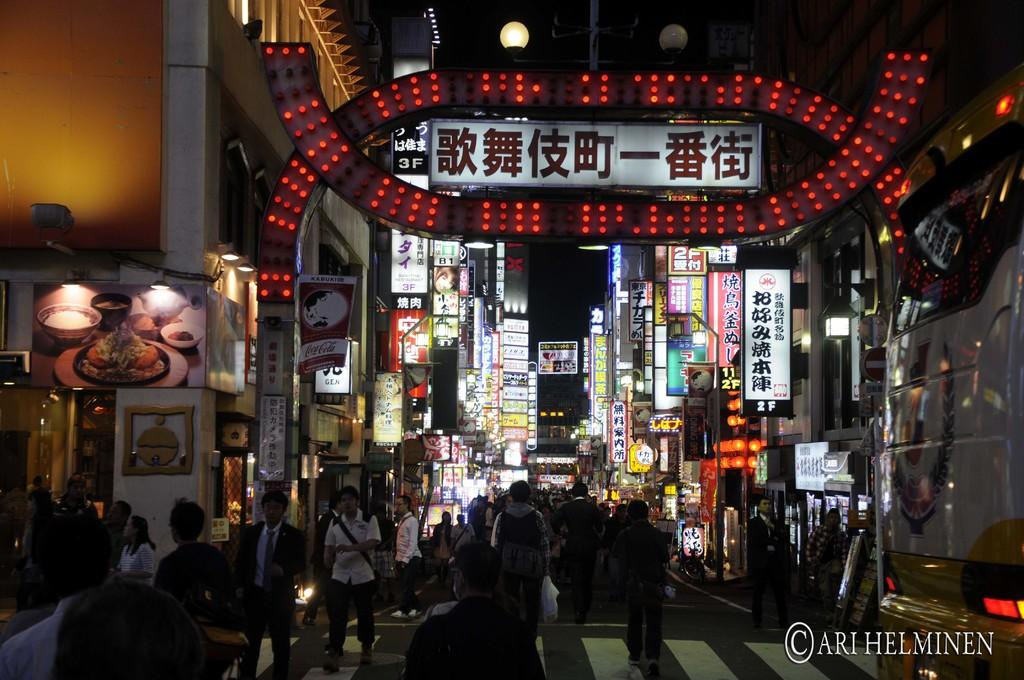How many people are in the group visible in the image? There is a group of people standing in the image, but the exact number cannot be determined from the provided facts. What type of vehicle is in the image? There is a vehicle in the image, but its specific make or model cannot be determined from the provided facts. What type of structures are visible in the image? There are buildings in the image, but their specific architectural styles or purposes cannot be determined from the provided facts. What are the boards in the image used for? The purpose of the boards in the image cannot be determined from the provided facts. What type of lights are in the image? The type of lights in the image cannot be determined from the provided facts. Is there any indication of the image's source or ownership? Yes, there is a watermark on the image. Who is the expert in the image providing advice on credit? There is no expert or advice on credit present in the image. What type of advertisement is visible on the boards in the image? There is no advertisement visible on the boards in the image. 